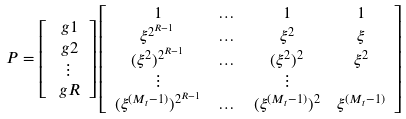Convert formula to latex. <formula><loc_0><loc_0><loc_500><loc_500>P & = \left [ \begin{array} { c } \ g { 1 } \\ \ g { 2 } \\ \vdots \\ \ g { R } \end{array} \right ] \left [ \begin{array} { c c c c } 1 & \dots & 1 & 1 \\ \xi ^ { 2 ^ { R - 1 } } & \dots & \xi ^ { 2 } & \xi \\ ( \xi ^ { 2 } ) ^ { 2 ^ { R - 1 } } & \dots & ( \xi ^ { 2 } ) ^ { 2 } & \xi ^ { 2 } \\ \vdots & & \vdots & \\ ( \xi ^ { ( M _ { t } - 1 ) } ) ^ { 2 ^ { R - 1 } } & \dots & ( \xi ^ { ( M _ { t } - 1 ) } ) ^ { 2 } & \xi ^ { ( M _ { t } - 1 ) } \\ \end{array} \right ]</formula> 